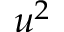<formula> <loc_0><loc_0><loc_500><loc_500>u ^ { 2 }</formula> 